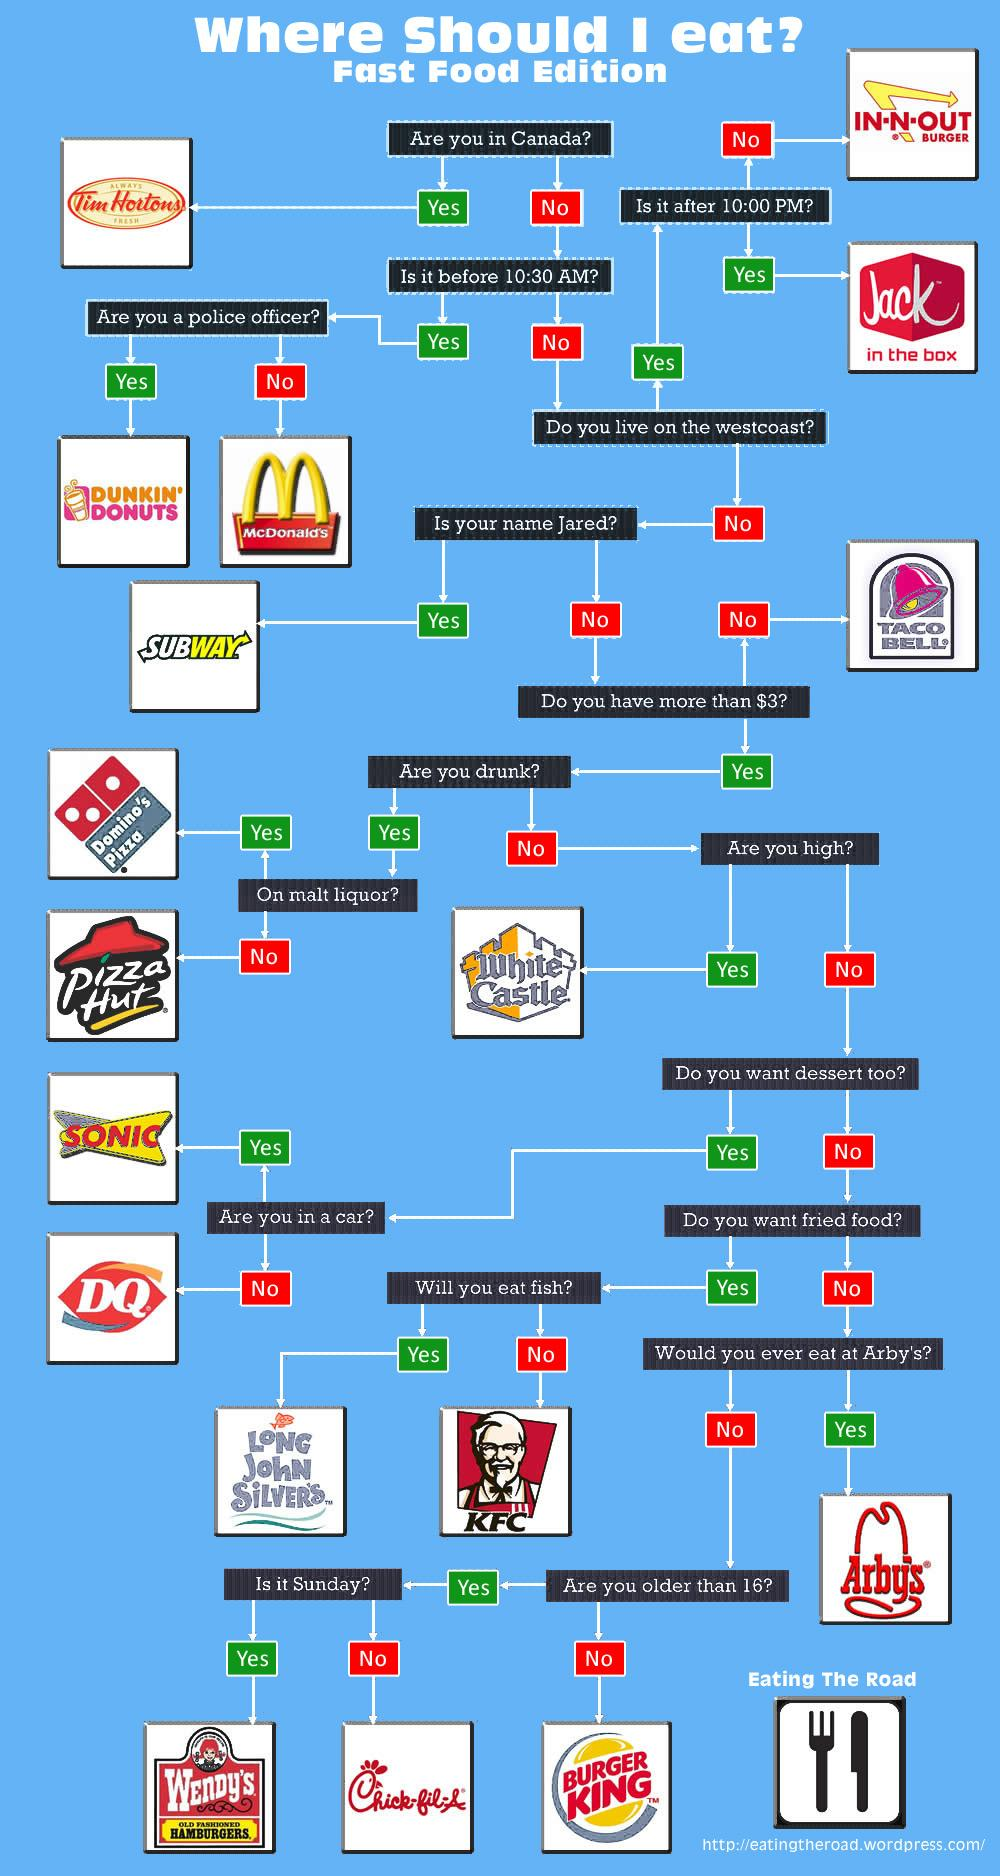Indicate a few pertinent items in this graphic. There have been 18 eating joints mentioned in this conversation. If I do not consume fish, I would choose to dine at KFC. If you are in Canada, you should eat at Tim Hortons. If I were to visit a fast-food restaurant and have a budget of less than $3, I would choose to dine at Taco Bell. If I am in a car, I can go to SONIC. 